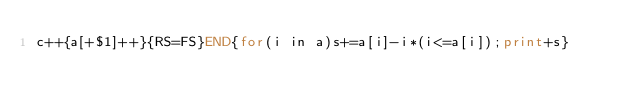Convert code to text. <code><loc_0><loc_0><loc_500><loc_500><_Awk_>c++{a[+$1]++}{RS=FS}END{for(i in a)s+=a[i]-i*(i<=a[i]);print+s}</code> 